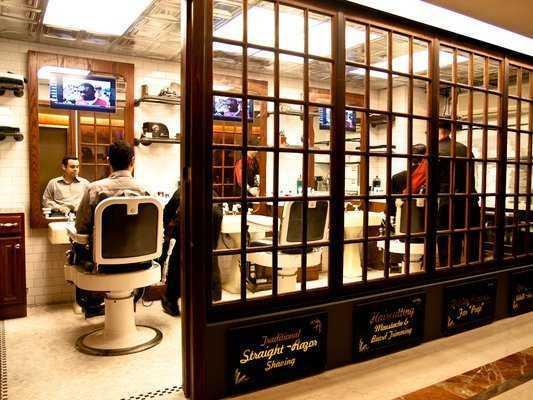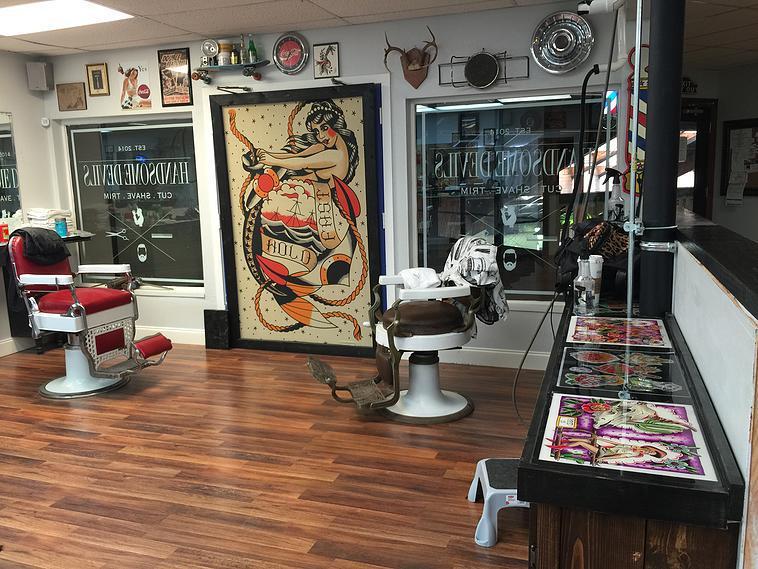The first image is the image on the left, the second image is the image on the right. Given the left and right images, does the statement "There are at least two people in the image on the right." hold true? Answer yes or no. No. 